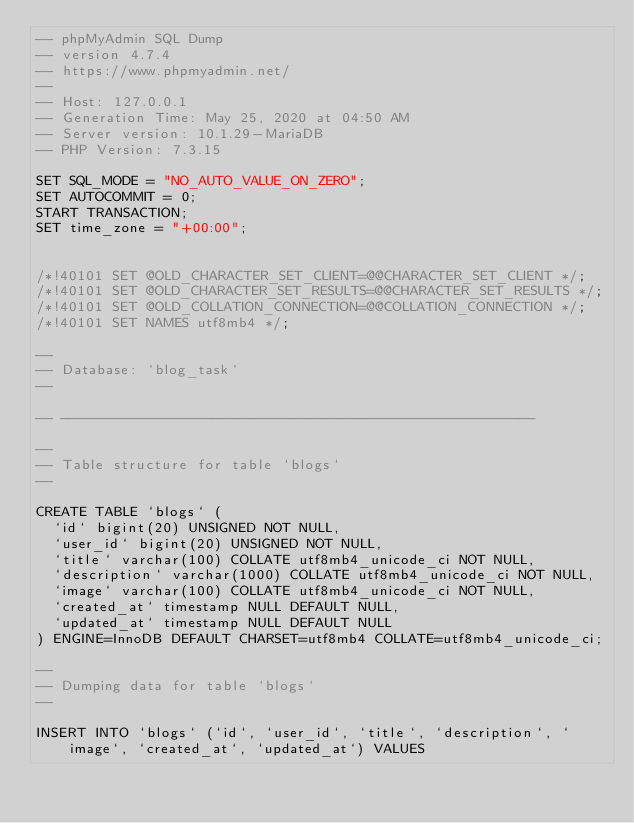Convert code to text. <code><loc_0><loc_0><loc_500><loc_500><_SQL_>-- phpMyAdmin SQL Dump
-- version 4.7.4
-- https://www.phpmyadmin.net/
--
-- Host: 127.0.0.1
-- Generation Time: May 25, 2020 at 04:50 AM
-- Server version: 10.1.29-MariaDB
-- PHP Version: 7.3.15

SET SQL_MODE = "NO_AUTO_VALUE_ON_ZERO";
SET AUTOCOMMIT = 0;
START TRANSACTION;
SET time_zone = "+00:00";


/*!40101 SET @OLD_CHARACTER_SET_CLIENT=@@CHARACTER_SET_CLIENT */;
/*!40101 SET @OLD_CHARACTER_SET_RESULTS=@@CHARACTER_SET_RESULTS */;
/*!40101 SET @OLD_COLLATION_CONNECTION=@@COLLATION_CONNECTION */;
/*!40101 SET NAMES utf8mb4 */;

--
-- Database: `blog_task`
--

-- --------------------------------------------------------

--
-- Table structure for table `blogs`
--

CREATE TABLE `blogs` (
  `id` bigint(20) UNSIGNED NOT NULL,
  `user_id` bigint(20) UNSIGNED NOT NULL,
  `title` varchar(100) COLLATE utf8mb4_unicode_ci NOT NULL,
  `description` varchar(1000) COLLATE utf8mb4_unicode_ci NOT NULL,
  `image` varchar(100) COLLATE utf8mb4_unicode_ci NOT NULL,
  `created_at` timestamp NULL DEFAULT NULL,
  `updated_at` timestamp NULL DEFAULT NULL
) ENGINE=InnoDB DEFAULT CHARSET=utf8mb4 COLLATE=utf8mb4_unicode_ci;

--
-- Dumping data for table `blogs`
--

INSERT INTO `blogs` (`id`, `user_id`, `title`, `description`, `image`, `created_at`, `updated_at`) VALUES</code> 